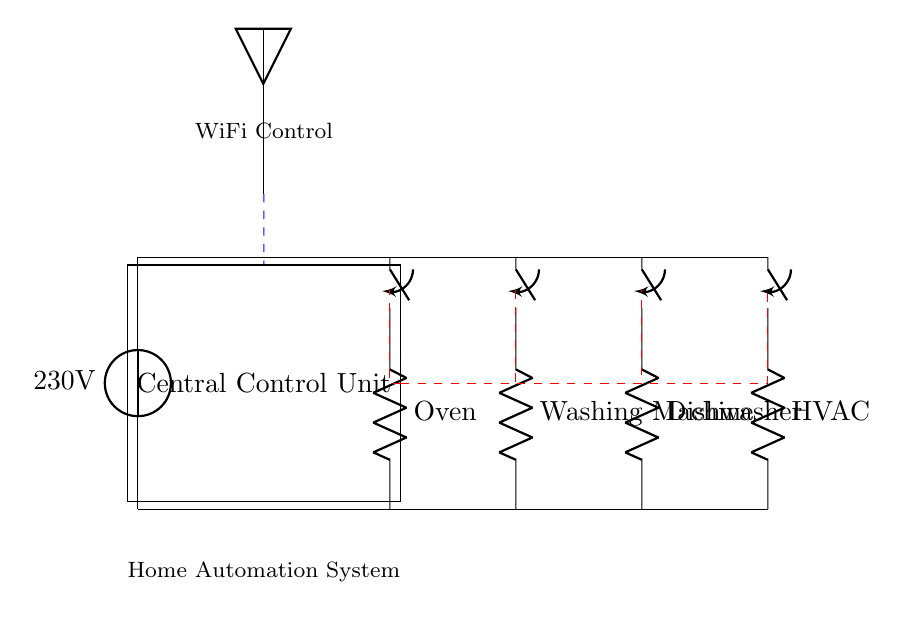What is the voltage supply to the circuit? The voltage supply is indicated by the voltage source symbol connected at the top of the circuit. The label next to it states it is 230 volts.
Answer: 230 volts What appliances are present in the circuit? Each appliance is labeled next to a resistor symbol connected to the switches. The appliances listed are Oven, Washing Machine, Dishwasher, and HVAC.
Answer: Oven, Washing Machine, Dishwasher, HVAC How many switches are utilized in this circuit? There is one switch for each of the four appliances shown in the diagram. Therefore, counting the number of switches gives us four.
Answer: Four What is the function of the Central Control Unit? The Central Control Unit is represented as a rectangle with a label that suggests it manages the operation of the appliances through control lines, indicating a home automation role.
Answer: Home automation How does the control unit communicate with the appliances? The control unit is connected to each appliance using dashed red lines, which suggests wireless communication (indicated by the WiFi symbol) and control logic, allowing it to manage the switches.
Answer: WiFi What type of system is illustrated by this circuit? The presence of high power appliances controlled by a central entity suggests this is a home automation system designed to manage multiple high-power appliances.
Answer: Home automation system 